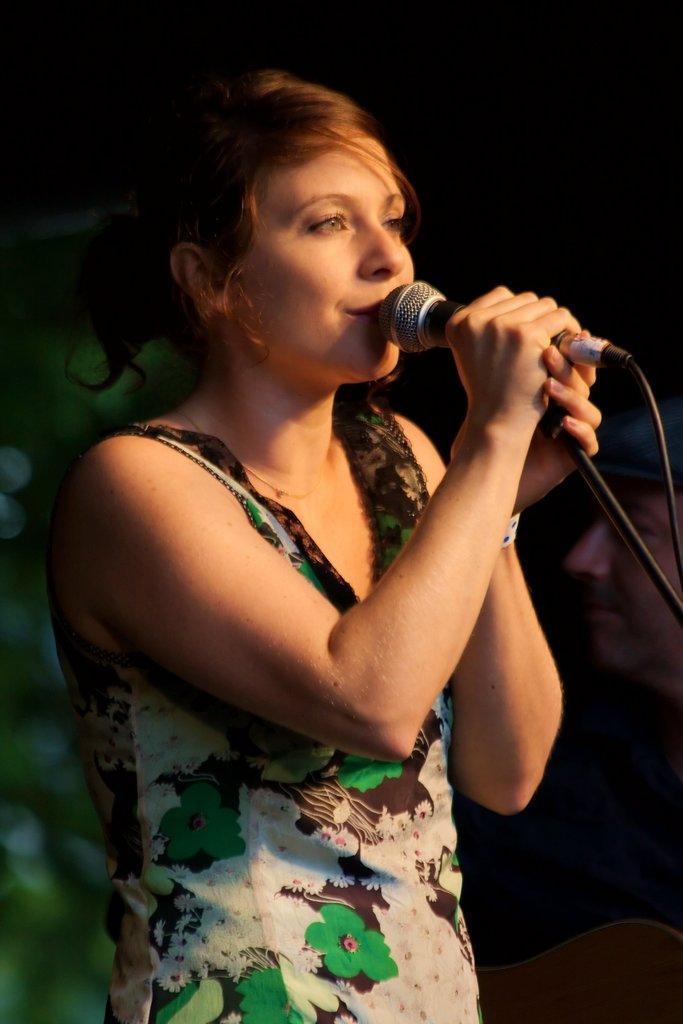Who is the main subject in the image? There is a woman in the image. What is the woman holding in the image? The woman is holding a microphone. What is the woman doing in the image? The woman is singing. What can be observed about the background of the image? The background of the image is dark. How many stars can be seen in the image? There are no stars visible in the image. What number is associated with the day the image was taken? The provided facts do not mention the day the image was taken, so it is impossible to determine any associated numbers. 